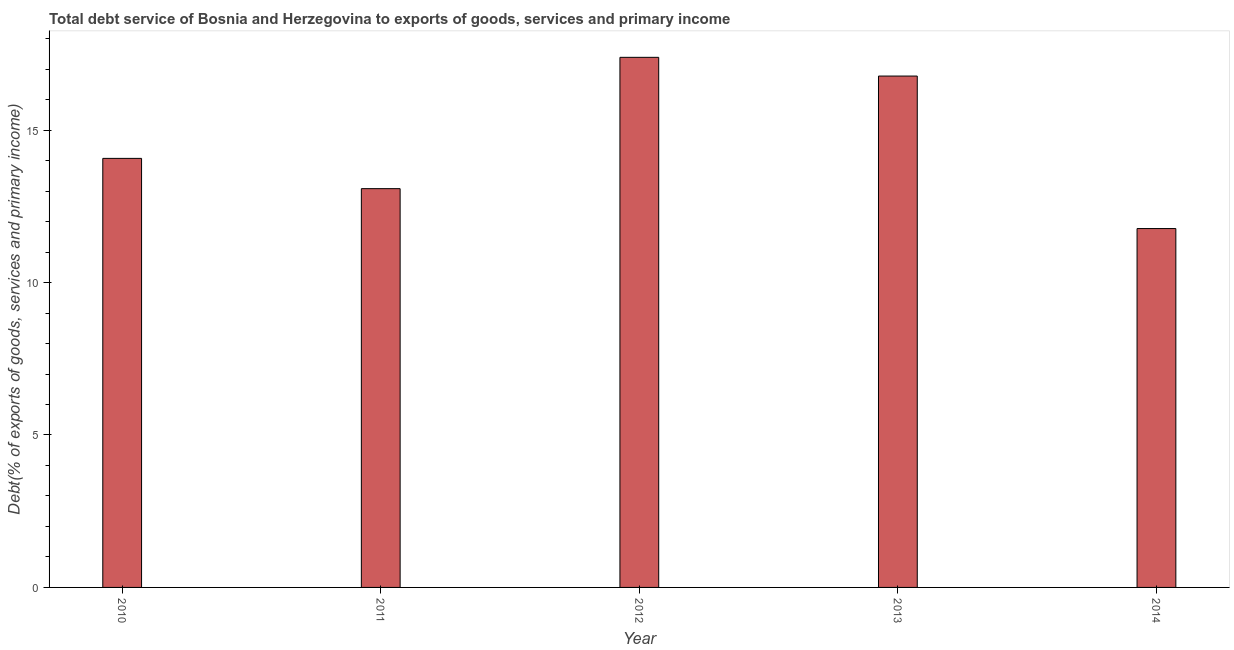Does the graph contain any zero values?
Your response must be concise. No. Does the graph contain grids?
Offer a terse response. No. What is the title of the graph?
Keep it short and to the point. Total debt service of Bosnia and Herzegovina to exports of goods, services and primary income. What is the label or title of the Y-axis?
Provide a short and direct response. Debt(% of exports of goods, services and primary income). What is the total debt service in 2011?
Your response must be concise. 13.08. Across all years, what is the maximum total debt service?
Give a very brief answer. 17.39. Across all years, what is the minimum total debt service?
Make the answer very short. 11.77. In which year was the total debt service maximum?
Provide a short and direct response. 2012. In which year was the total debt service minimum?
Ensure brevity in your answer.  2014. What is the sum of the total debt service?
Your answer should be compact. 73.09. What is the difference between the total debt service in 2012 and 2014?
Provide a short and direct response. 5.62. What is the average total debt service per year?
Your answer should be compact. 14.62. What is the median total debt service?
Give a very brief answer. 14.07. Do a majority of the years between 2010 and 2013 (inclusive) have total debt service greater than 6 %?
Offer a very short reply. Yes. What is the ratio of the total debt service in 2011 to that in 2012?
Your answer should be very brief. 0.75. Is the total debt service in 2010 less than that in 2011?
Your response must be concise. No. Is the difference between the total debt service in 2010 and 2014 greater than the difference between any two years?
Keep it short and to the point. No. What is the difference between the highest and the second highest total debt service?
Keep it short and to the point. 0.61. Is the sum of the total debt service in 2011 and 2012 greater than the maximum total debt service across all years?
Provide a succinct answer. Yes. What is the difference between the highest and the lowest total debt service?
Your answer should be compact. 5.62. In how many years, is the total debt service greater than the average total debt service taken over all years?
Make the answer very short. 2. Are the values on the major ticks of Y-axis written in scientific E-notation?
Your answer should be very brief. No. What is the Debt(% of exports of goods, services and primary income) in 2010?
Your answer should be compact. 14.07. What is the Debt(% of exports of goods, services and primary income) of 2011?
Give a very brief answer. 13.08. What is the Debt(% of exports of goods, services and primary income) in 2012?
Provide a succinct answer. 17.39. What is the Debt(% of exports of goods, services and primary income) of 2013?
Make the answer very short. 16.77. What is the Debt(% of exports of goods, services and primary income) in 2014?
Offer a terse response. 11.77. What is the difference between the Debt(% of exports of goods, services and primary income) in 2010 and 2012?
Your response must be concise. -3.31. What is the difference between the Debt(% of exports of goods, services and primary income) in 2010 and 2013?
Your answer should be compact. -2.7. What is the difference between the Debt(% of exports of goods, services and primary income) in 2010 and 2014?
Ensure brevity in your answer.  2.3. What is the difference between the Debt(% of exports of goods, services and primary income) in 2011 and 2012?
Your answer should be compact. -4.31. What is the difference between the Debt(% of exports of goods, services and primary income) in 2011 and 2013?
Ensure brevity in your answer.  -3.69. What is the difference between the Debt(% of exports of goods, services and primary income) in 2011 and 2014?
Offer a terse response. 1.31. What is the difference between the Debt(% of exports of goods, services and primary income) in 2012 and 2013?
Your answer should be very brief. 0.61. What is the difference between the Debt(% of exports of goods, services and primary income) in 2012 and 2014?
Provide a short and direct response. 5.62. What is the difference between the Debt(% of exports of goods, services and primary income) in 2013 and 2014?
Give a very brief answer. 5. What is the ratio of the Debt(% of exports of goods, services and primary income) in 2010 to that in 2011?
Give a very brief answer. 1.08. What is the ratio of the Debt(% of exports of goods, services and primary income) in 2010 to that in 2012?
Your answer should be compact. 0.81. What is the ratio of the Debt(% of exports of goods, services and primary income) in 2010 to that in 2013?
Ensure brevity in your answer.  0.84. What is the ratio of the Debt(% of exports of goods, services and primary income) in 2010 to that in 2014?
Keep it short and to the point. 1.2. What is the ratio of the Debt(% of exports of goods, services and primary income) in 2011 to that in 2012?
Ensure brevity in your answer.  0.75. What is the ratio of the Debt(% of exports of goods, services and primary income) in 2011 to that in 2013?
Your response must be concise. 0.78. What is the ratio of the Debt(% of exports of goods, services and primary income) in 2011 to that in 2014?
Provide a short and direct response. 1.11. What is the ratio of the Debt(% of exports of goods, services and primary income) in 2012 to that in 2014?
Give a very brief answer. 1.48. What is the ratio of the Debt(% of exports of goods, services and primary income) in 2013 to that in 2014?
Your response must be concise. 1.43. 